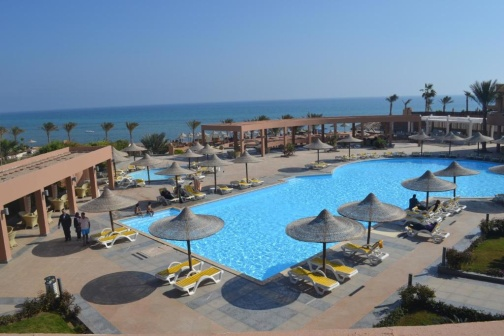Describe the amenities available at this resort. This resort offers a host of top-notch amenities designed to cater to a variety of guest preferences. At its heart lies a beautifully shaped swimming pool, complete with numerous lounge chairs and thatched umbrellas for ultimate relaxation. Surrounding the pool, an array of palm trees adds a tropical touch. Guests can enjoy shaded areas under open-air structures, ideal for dining or lounging. In the background, a prominent resort building provides a range of accommodations with stunning ocean views. Faciltities likely include beachfront access, water sports, dining venues, and spa services, ensuring a comprehensive and luxurious experience. 